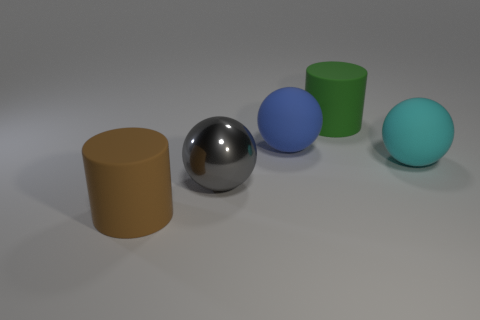Subtract all red balls. Subtract all gray cubes. How many balls are left? 3 Add 4 big gray blocks. How many objects exist? 9 Subtract all cylinders. How many objects are left? 3 Subtract all brown rubber cylinders. Subtract all large blue things. How many objects are left? 3 Add 2 rubber objects. How many rubber objects are left? 6 Add 4 small gray things. How many small gray things exist? 4 Subtract 0 brown spheres. How many objects are left? 5 